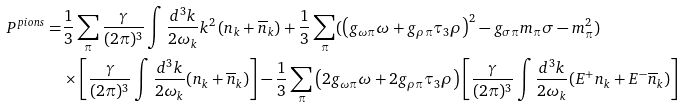Convert formula to latex. <formula><loc_0><loc_0><loc_500><loc_500>P ^ { p i o n s } = & \frac { 1 } { 3 } \sum _ { \pi } \frac { \gamma } { ( 2 \pi ) ^ { 3 } } \int \frac { d ^ { 3 } k } { 2 \omega _ { k } } k ^ { 2 } \left ( n _ { k } + { \overline { n } } _ { k } \right ) + \frac { 1 } { 3 } \sum _ { \pi } ( \left ( g _ { \omega \pi } \omega + g _ { \rho \pi } \tau _ { 3 } \rho \right ) ^ { 2 } - g _ { \sigma \pi } m _ { \pi } \sigma - m _ { \pi } ^ { 2 } ) \\ & \times \left [ \frac { \gamma } { ( 2 \pi ) ^ { 3 } } \int \frac { d ^ { 3 } k } { 2 \omega _ { k } } ( n _ { k } + { \overline { n } } _ { k } ) \right ] - \frac { 1 } { 3 } \sum _ { \pi } \left ( 2 g _ { \omega \pi } \omega + 2 g _ { \rho \pi } \tau _ { 3 } \rho \right ) \left [ \frac { \gamma } { ( 2 \pi ) ^ { 3 } } \int \frac { d ^ { 3 } k } { 2 \omega _ { k } } ( E ^ { + } n _ { k } + E ^ { - } { \overline { n } } _ { k } ) \right ]</formula> 